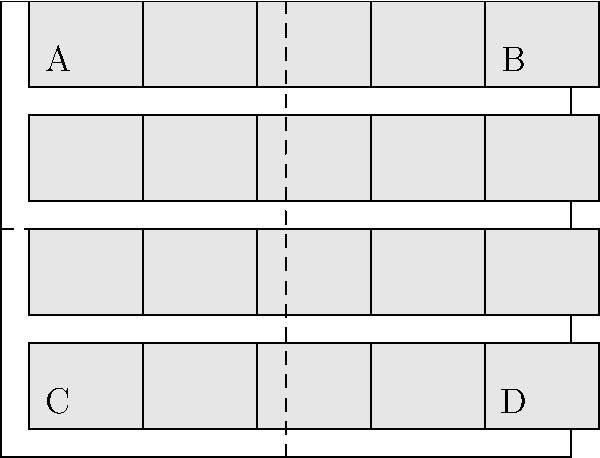In an effort to optimize the layout of cubicles in your IT company's office space, you've designed a rectangular floor plan as shown above. The office measures 10 meters wide and 8 meters long, with 20 cubicles arranged in a 4x5 grid. Each cubicle is 2 meters wide and 1.5 meters deep, with 0.5-meter gaps between them for walkways. Two main walkways divide the office into four quadrants (A, B, C, and D).

To minimize distractions and improve productivity, you want to calculate the total area of the walkways. What percentage of the total office space is dedicated to walkways? Let's approach this step-by-step:

1) Calculate the total office area:
   $$\text{Total Area} = 10\text{ m} \times 8\text{ m} = 80\text{ m}^2$$

2) Calculate the area occupied by cubicles:
   Each cubicle: $$2\text{ m} \times 1.5\text{ m} = 3\text{ m}^2$$
   Total cubicle area: $$20 \times 3\text{ m}^2 = 60\text{ m}^2$$

3) Calculate the walkway area:
   $$\text{Walkway Area} = \text{Total Area} - \text{Cubicle Area}$$
   $$\text{Walkway Area} = 80\text{ m}^2 - 60\text{ m}^2 = 20\text{ m}^2$$

4) Calculate the percentage of walkway area:
   $$\text{Percentage} = \frac{\text{Walkway Area}}{\text{Total Area}} \times 100\%$$
   $$\text{Percentage} = \frac{20\text{ m}^2}{80\text{ m}^2} \times 100\% = 25\%$$

Therefore, 25% of the total office space is dedicated to walkways.
Answer: 25% 